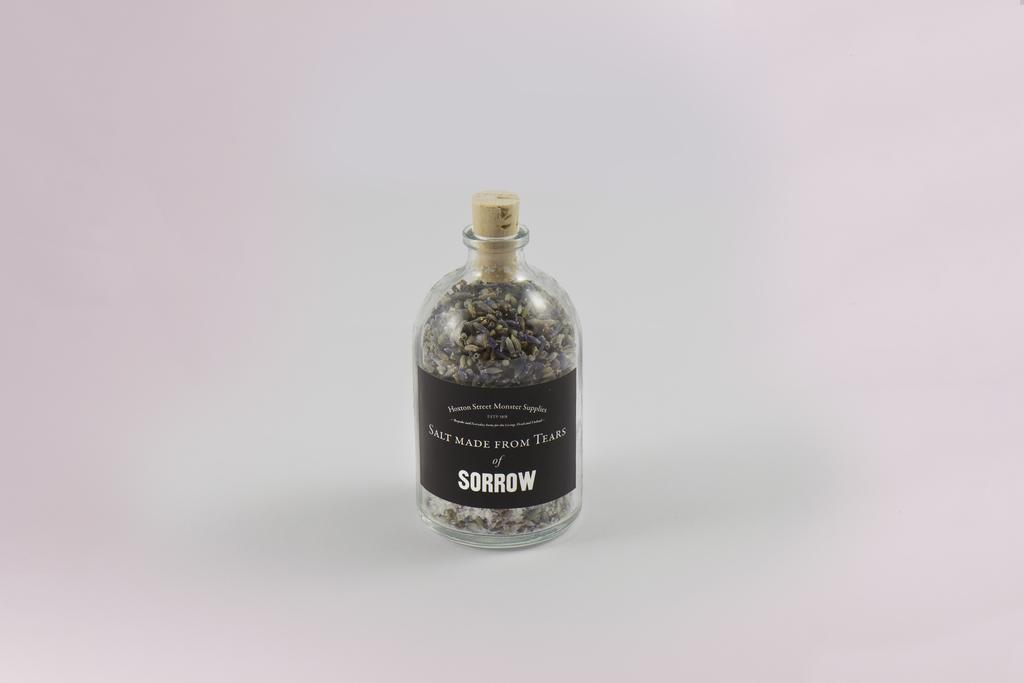Provide a one-sentence caption for the provided image. A bottle labeled Salt Made From Tears of Sorrow. 